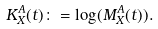<formula> <loc_0><loc_0><loc_500><loc_500>K ^ { A } _ { X } ( t ) \colon = \log ( M ^ { A } _ { X } ( t ) ) .</formula> 